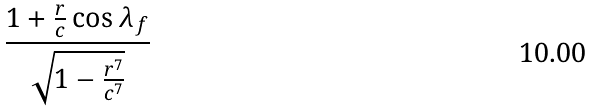Convert formula to latex. <formula><loc_0><loc_0><loc_500><loc_500>\frac { 1 + \frac { r } { c } \cos \lambda _ { f } } { \sqrt { 1 - \frac { r ^ { 7 } } { c ^ { 7 } } } }</formula> 